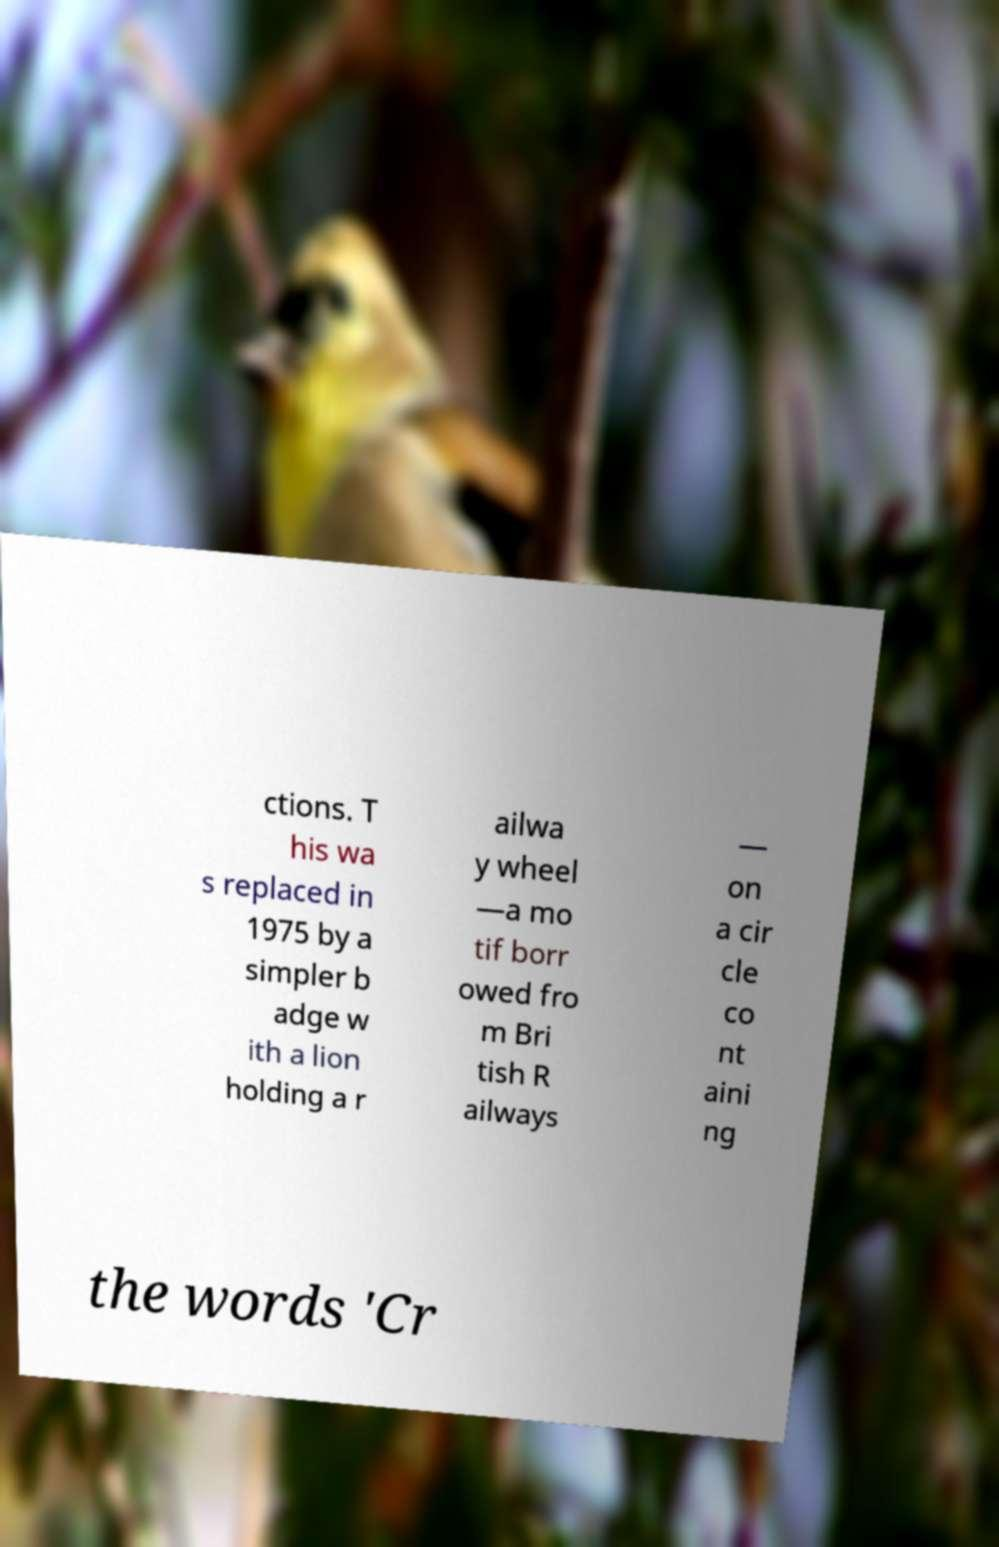Could you extract and type out the text from this image? ctions. T his wa s replaced in 1975 by a simpler b adge w ith a lion holding a r ailwa y wheel ―a mo tif borr owed fro m Bri tish R ailways ― on a cir cle co nt aini ng the words 'Cr 